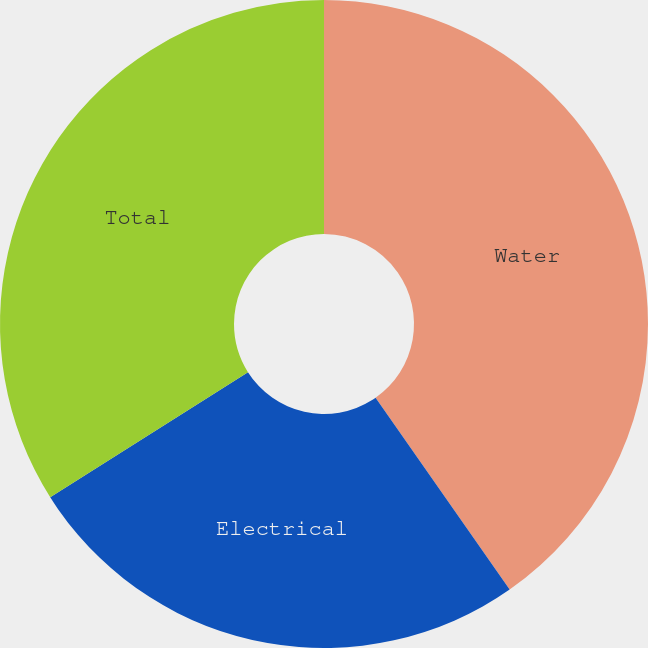Convert chart. <chart><loc_0><loc_0><loc_500><loc_500><pie_chart><fcel>Water<fcel>Electrical<fcel>Total<nl><fcel>40.29%<fcel>25.73%<fcel>33.98%<nl></chart> 